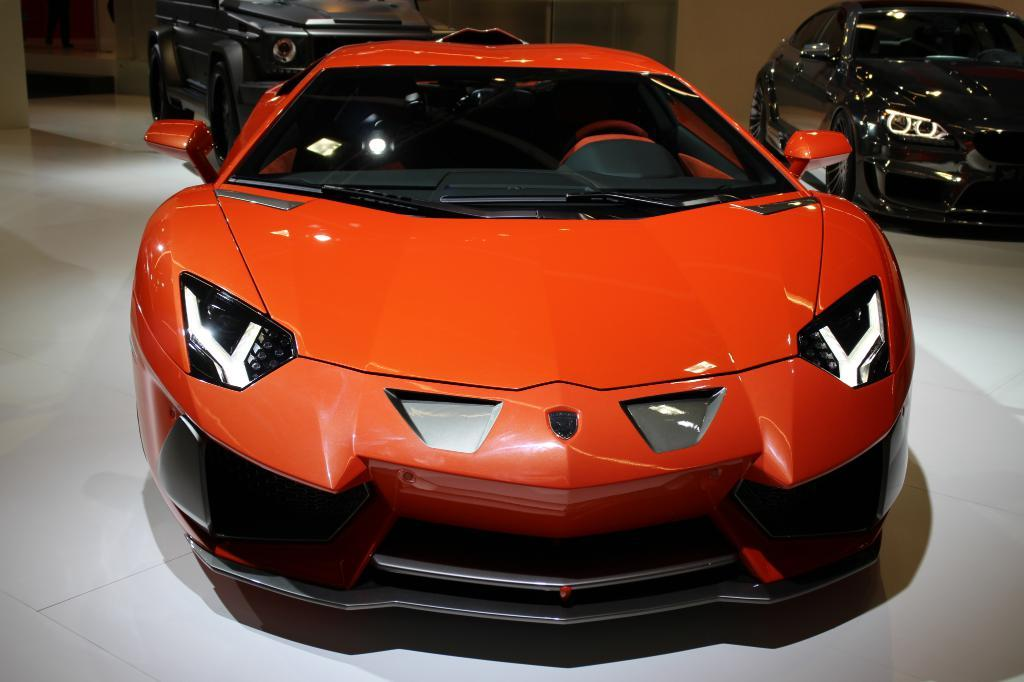What is the main subject of the image? The main subject of the image is a group of cars parked in the center. Where are the cars located in relation to the ground? The cars are parked on the ground. What can be seen in the background of the image? There is a wall visible in the background, along with other objects. What type of stamp can be seen on the hood of the car in the image? There is no stamp visible on the hood of any car in the image. What historical event is being commemorated by the cars in the image? The image does not depict any historical event or commemoration; it simply shows a group of cars parked on the ground. 